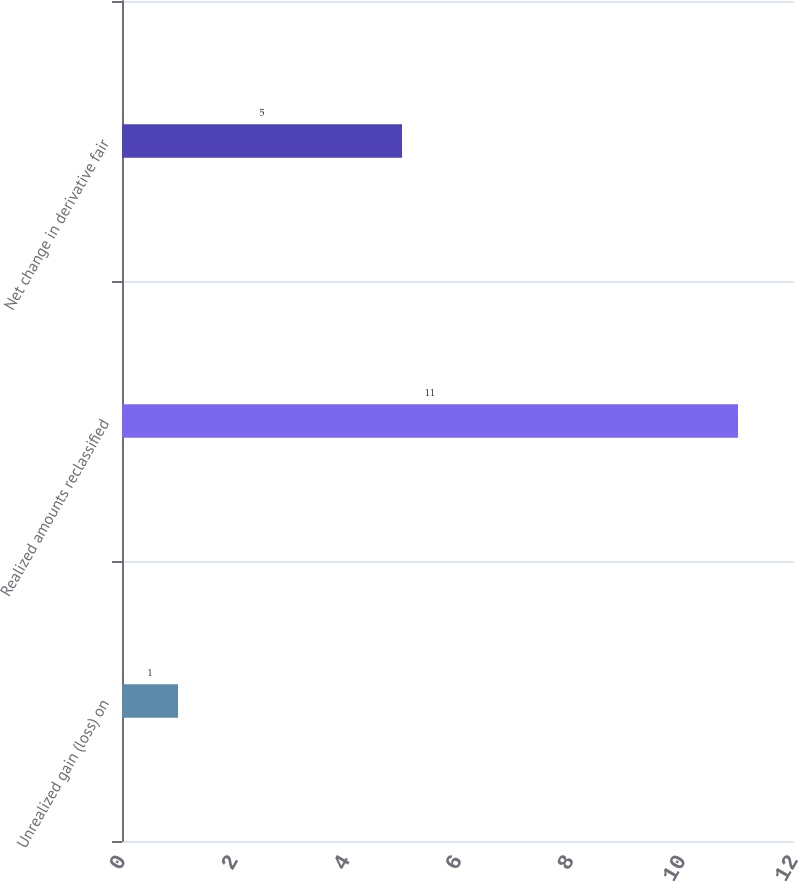Convert chart. <chart><loc_0><loc_0><loc_500><loc_500><bar_chart><fcel>Unrealized gain (loss) on<fcel>Realized amounts reclassified<fcel>Net change in derivative fair<nl><fcel>1<fcel>11<fcel>5<nl></chart> 